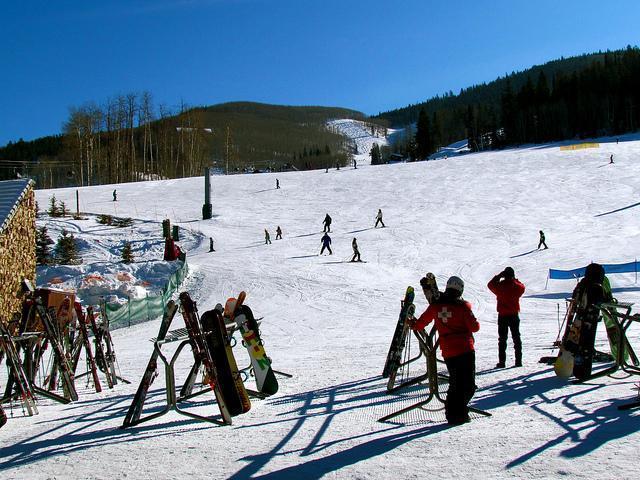How many people are there?
Give a very brief answer. 2. How many snowboards can be seen?
Give a very brief answer. 2. How many dogs is this?
Give a very brief answer. 0. 